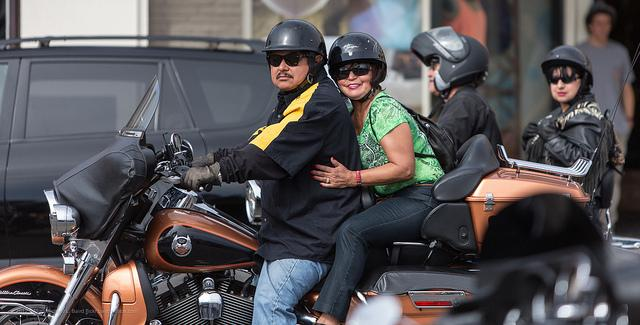Who is the happiest in the picture? Please explain your reasoning. front woman. Th front woman is smiling and her teeth can be seen. 